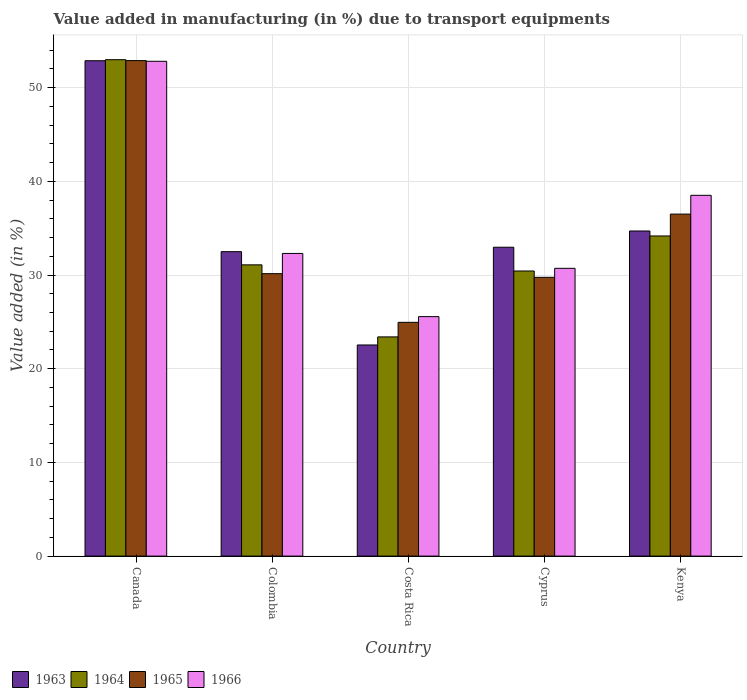How many different coloured bars are there?
Provide a succinct answer. 4. Are the number of bars on each tick of the X-axis equal?
Keep it short and to the point. Yes. What is the percentage of value added in manufacturing due to transport equipments in 1965 in Costa Rica?
Give a very brief answer. 24.95. Across all countries, what is the maximum percentage of value added in manufacturing due to transport equipments in 1963?
Your answer should be compact. 52.87. Across all countries, what is the minimum percentage of value added in manufacturing due to transport equipments in 1963?
Offer a very short reply. 22.53. In which country was the percentage of value added in manufacturing due to transport equipments in 1965 minimum?
Make the answer very short. Costa Rica. What is the total percentage of value added in manufacturing due to transport equipments in 1966 in the graph?
Give a very brief answer. 179.9. What is the difference between the percentage of value added in manufacturing due to transport equipments in 1966 in Canada and that in Costa Rica?
Ensure brevity in your answer.  27.25. What is the difference between the percentage of value added in manufacturing due to transport equipments in 1965 in Cyprus and the percentage of value added in manufacturing due to transport equipments in 1963 in Colombia?
Offer a very short reply. -2.74. What is the average percentage of value added in manufacturing due to transport equipments in 1965 per country?
Offer a very short reply. 34.85. What is the difference between the percentage of value added in manufacturing due to transport equipments of/in 1964 and percentage of value added in manufacturing due to transport equipments of/in 1965 in Colombia?
Offer a very short reply. 0.94. What is the ratio of the percentage of value added in manufacturing due to transport equipments in 1966 in Costa Rica to that in Kenya?
Make the answer very short. 0.66. Is the percentage of value added in manufacturing due to transport equipments in 1964 in Colombia less than that in Cyprus?
Make the answer very short. No. Is the difference between the percentage of value added in manufacturing due to transport equipments in 1964 in Colombia and Costa Rica greater than the difference between the percentage of value added in manufacturing due to transport equipments in 1965 in Colombia and Costa Rica?
Make the answer very short. Yes. What is the difference between the highest and the second highest percentage of value added in manufacturing due to transport equipments in 1966?
Offer a terse response. -20.51. What is the difference between the highest and the lowest percentage of value added in manufacturing due to transport equipments in 1963?
Ensure brevity in your answer.  30.34. In how many countries, is the percentage of value added in manufacturing due to transport equipments in 1964 greater than the average percentage of value added in manufacturing due to transport equipments in 1964 taken over all countries?
Give a very brief answer. 1. What does the 3rd bar from the left in Canada represents?
Make the answer very short. 1965. What does the 2nd bar from the right in Costa Rica represents?
Make the answer very short. 1965. How many countries are there in the graph?
Provide a short and direct response. 5. What is the difference between two consecutive major ticks on the Y-axis?
Provide a succinct answer. 10. Are the values on the major ticks of Y-axis written in scientific E-notation?
Ensure brevity in your answer.  No. Does the graph contain grids?
Provide a succinct answer. Yes. What is the title of the graph?
Make the answer very short. Value added in manufacturing (in %) due to transport equipments. What is the label or title of the X-axis?
Your response must be concise. Country. What is the label or title of the Y-axis?
Make the answer very short. Value added (in %). What is the Value added (in %) of 1963 in Canada?
Offer a terse response. 52.87. What is the Value added (in %) in 1964 in Canada?
Offer a terse response. 52.98. What is the Value added (in %) of 1965 in Canada?
Keep it short and to the point. 52.89. What is the Value added (in %) in 1966 in Canada?
Your answer should be compact. 52.81. What is the Value added (in %) of 1963 in Colombia?
Your answer should be very brief. 32.49. What is the Value added (in %) of 1964 in Colombia?
Make the answer very short. 31.09. What is the Value added (in %) in 1965 in Colombia?
Offer a terse response. 30.15. What is the Value added (in %) in 1966 in Colombia?
Make the answer very short. 32.3. What is the Value added (in %) of 1963 in Costa Rica?
Offer a terse response. 22.53. What is the Value added (in %) of 1964 in Costa Rica?
Offer a very short reply. 23.4. What is the Value added (in %) in 1965 in Costa Rica?
Your answer should be compact. 24.95. What is the Value added (in %) of 1966 in Costa Rica?
Ensure brevity in your answer.  25.56. What is the Value added (in %) in 1963 in Cyprus?
Your answer should be compact. 32.97. What is the Value added (in %) in 1964 in Cyprus?
Your answer should be very brief. 30.43. What is the Value added (in %) in 1965 in Cyprus?
Offer a very short reply. 29.75. What is the Value added (in %) in 1966 in Cyprus?
Your answer should be very brief. 30.72. What is the Value added (in %) of 1963 in Kenya?
Offer a very short reply. 34.7. What is the Value added (in %) of 1964 in Kenya?
Provide a succinct answer. 34.17. What is the Value added (in %) in 1965 in Kenya?
Your response must be concise. 36.5. What is the Value added (in %) of 1966 in Kenya?
Provide a short and direct response. 38.51. Across all countries, what is the maximum Value added (in %) in 1963?
Your response must be concise. 52.87. Across all countries, what is the maximum Value added (in %) of 1964?
Ensure brevity in your answer.  52.98. Across all countries, what is the maximum Value added (in %) in 1965?
Offer a terse response. 52.89. Across all countries, what is the maximum Value added (in %) in 1966?
Ensure brevity in your answer.  52.81. Across all countries, what is the minimum Value added (in %) in 1963?
Give a very brief answer. 22.53. Across all countries, what is the minimum Value added (in %) in 1964?
Give a very brief answer. 23.4. Across all countries, what is the minimum Value added (in %) in 1965?
Your answer should be very brief. 24.95. Across all countries, what is the minimum Value added (in %) of 1966?
Offer a very short reply. 25.56. What is the total Value added (in %) of 1963 in the graph?
Provide a short and direct response. 175.57. What is the total Value added (in %) of 1964 in the graph?
Ensure brevity in your answer.  172.06. What is the total Value added (in %) of 1965 in the graph?
Offer a very short reply. 174.24. What is the total Value added (in %) of 1966 in the graph?
Provide a succinct answer. 179.9. What is the difference between the Value added (in %) in 1963 in Canada and that in Colombia?
Your answer should be very brief. 20.38. What is the difference between the Value added (in %) of 1964 in Canada and that in Colombia?
Provide a succinct answer. 21.9. What is the difference between the Value added (in %) in 1965 in Canada and that in Colombia?
Offer a terse response. 22.74. What is the difference between the Value added (in %) of 1966 in Canada and that in Colombia?
Make the answer very short. 20.51. What is the difference between the Value added (in %) of 1963 in Canada and that in Costa Rica?
Provide a succinct answer. 30.34. What is the difference between the Value added (in %) in 1964 in Canada and that in Costa Rica?
Provide a succinct answer. 29.59. What is the difference between the Value added (in %) in 1965 in Canada and that in Costa Rica?
Your answer should be compact. 27.93. What is the difference between the Value added (in %) in 1966 in Canada and that in Costa Rica?
Your answer should be compact. 27.25. What is the difference between the Value added (in %) of 1963 in Canada and that in Cyprus?
Ensure brevity in your answer.  19.91. What is the difference between the Value added (in %) of 1964 in Canada and that in Cyprus?
Your response must be concise. 22.55. What is the difference between the Value added (in %) of 1965 in Canada and that in Cyprus?
Your answer should be very brief. 23.13. What is the difference between the Value added (in %) in 1966 in Canada and that in Cyprus?
Your answer should be very brief. 22.1. What is the difference between the Value added (in %) of 1963 in Canada and that in Kenya?
Your answer should be very brief. 18.17. What is the difference between the Value added (in %) in 1964 in Canada and that in Kenya?
Your answer should be very brief. 18.81. What is the difference between the Value added (in %) of 1965 in Canada and that in Kenya?
Provide a short and direct response. 16.38. What is the difference between the Value added (in %) in 1966 in Canada and that in Kenya?
Your answer should be very brief. 14.3. What is the difference between the Value added (in %) of 1963 in Colombia and that in Costa Rica?
Offer a terse response. 9.96. What is the difference between the Value added (in %) of 1964 in Colombia and that in Costa Rica?
Your response must be concise. 7.69. What is the difference between the Value added (in %) in 1965 in Colombia and that in Costa Rica?
Make the answer very short. 5.2. What is the difference between the Value added (in %) in 1966 in Colombia and that in Costa Rica?
Your answer should be compact. 6.74. What is the difference between the Value added (in %) in 1963 in Colombia and that in Cyprus?
Your answer should be compact. -0.47. What is the difference between the Value added (in %) in 1964 in Colombia and that in Cyprus?
Offer a very short reply. 0.66. What is the difference between the Value added (in %) in 1965 in Colombia and that in Cyprus?
Provide a succinct answer. 0.39. What is the difference between the Value added (in %) of 1966 in Colombia and that in Cyprus?
Make the answer very short. 1.59. What is the difference between the Value added (in %) in 1963 in Colombia and that in Kenya?
Ensure brevity in your answer.  -2.21. What is the difference between the Value added (in %) of 1964 in Colombia and that in Kenya?
Ensure brevity in your answer.  -3.08. What is the difference between the Value added (in %) in 1965 in Colombia and that in Kenya?
Make the answer very short. -6.36. What is the difference between the Value added (in %) in 1966 in Colombia and that in Kenya?
Give a very brief answer. -6.2. What is the difference between the Value added (in %) in 1963 in Costa Rica and that in Cyprus?
Your answer should be very brief. -10.43. What is the difference between the Value added (in %) of 1964 in Costa Rica and that in Cyprus?
Your answer should be compact. -7.03. What is the difference between the Value added (in %) of 1965 in Costa Rica and that in Cyprus?
Give a very brief answer. -4.8. What is the difference between the Value added (in %) in 1966 in Costa Rica and that in Cyprus?
Your answer should be compact. -5.16. What is the difference between the Value added (in %) in 1963 in Costa Rica and that in Kenya?
Provide a succinct answer. -12.17. What is the difference between the Value added (in %) of 1964 in Costa Rica and that in Kenya?
Offer a terse response. -10.77. What is the difference between the Value added (in %) in 1965 in Costa Rica and that in Kenya?
Ensure brevity in your answer.  -11.55. What is the difference between the Value added (in %) of 1966 in Costa Rica and that in Kenya?
Your response must be concise. -12.95. What is the difference between the Value added (in %) of 1963 in Cyprus and that in Kenya?
Offer a terse response. -1.73. What is the difference between the Value added (in %) in 1964 in Cyprus and that in Kenya?
Ensure brevity in your answer.  -3.74. What is the difference between the Value added (in %) in 1965 in Cyprus and that in Kenya?
Ensure brevity in your answer.  -6.75. What is the difference between the Value added (in %) of 1966 in Cyprus and that in Kenya?
Provide a short and direct response. -7.79. What is the difference between the Value added (in %) in 1963 in Canada and the Value added (in %) in 1964 in Colombia?
Offer a terse response. 21.79. What is the difference between the Value added (in %) in 1963 in Canada and the Value added (in %) in 1965 in Colombia?
Provide a short and direct response. 22.73. What is the difference between the Value added (in %) in 1963 in Canada and the Value added (in %) in 1966 in Colombia?
Give a very brief answer. 20.57. What is the difference between the Value added (in %) of 1964 in Canada and the Value added (in %) of 1965 in Colombia?
Provide a succinct answer. 22.84. What is the difference between the Value added (in %) in 1964 in Canada and the Value added (in %) in 1966 in Colombia?
Your response must be concise. 20.68. What is the difference between the Value added (in %) of 1965 in Canada and the Value added (in %) of 1966 in Colombia?
Offer a terse response. 20.58. What is the difference between the Value added (in %) in 1963 in Canada and the Value added (in %) in 1964 in Costa Rica?
Your answer should be compact. 29.48. What is the difference between the Value added (in %) of 1963 in Canada and the Value added (in %) of 1965 in Costa Rica?
Make the answer very short. 27.92. What is the difference between the Value added (in %) in 1963 in Canada and the Value added (in %) in 1966 in Costa Rica?
Make the answer very short. 27.31. What is the difference between the Value added (in %) in 1964 in Canada and the Value added (in %) in 1965 in Costa Rica?
Offer a very short reply. 28.03. What is the difference between the Value added (in %) of 1964 in Canada and the Value added (in %) of 1966 in Costa Rica?
Provide a short and direct response. 27.42. What is the difference between the Value added (in %) of 1965 in Canada and the Value added (in %) of 1966 in Costa Rica?
Provide a short and direct response. 27.33. What is the difference between the Value added (in %) of 1963 in Canada and the Value added (in %) of 1964 in Cyprus?
Provide a short and direct response. 22.44. What is the difference between the Value added (in %) in 1963 in Canada and the Value added (in %) in 1965 in Cyprus?
Offer a terse response. 23.12. What is the difference between the Value added (in %) of 1963 in Canada and the Value added (in %) of 1966 in Cyprus?
Your answer should be compact. 22.16. What is the difference between the Value added (in %) of 1964 in Canada and the Value added (in %) of 1965 in Cyprus?
Make the answer very short. 23.23. What is the difference between the Value added (in %) of 1964 in Canada and the Value added (in %) of 1966 in Cyprus?
Keep it short and to the point. 22.27. What is the difference between the Value added (in %) in 1965 in Canada and the Value added (in %) in 1966 in Cyprus?
Offer a terse response. 22.17. What is the difference between the Value added (in %) of 1963 in Canada and the Value added (in %) of 1964 in Kenya?
Give a very brief answer. 18.7. What is the difference between the Value added (in %) in 1963 in Canada and the Value added (in %) in 1965 in Kenya?
Your answer should be very brief. 16.37. What is the difference between the Value added (in %) of 1963 in Canada and the Value added (in %) of 1966 in Kenya?
Your answer should be very brief. 14.37. What is the difference between the Value added (in %) in 1964 in Canada and the Value added (in %) in 1965 in Kenya?
Make the answer very short. 16.48. What is the difference between the Value added (in %) of 1964 in Canada and the Value added (in %) of 1966 in Kenya?
Give a very brief answer. 14.47. What is the difference between the Value added (in %) of 1965 in Canada and the Value added (in %) of 1966 in Kenya?
Ensure brevity in your answer.  14.38. What is the difference between the Value added (in %) in 1963 in Colombia and the Value added (in %) in 1964 in Costa Rica?
Your answer should be compact. 9.1. What is the difference between the Value added (in %) of 1963 in Colombia and the Value added (in %) of 1965 in Costa Rica?
Offer a terse response. 7.54. What is the difference between the Value added (in %) in 1963 in Colombia and the Value added (in %) in 1966 in Costa Rica?
Your answer should be very brief. 6.93. What is the difference between the Value added (in %) in 1964 in Colombia and the Value added (in %) in 1965 in Costa Rica?
Your response must be concise. 6.14. What is the difference between the Value added (in %) in 1964 in Colombia and the Value added (in %) in 1966 in Costa Rica?
Ensure brevity in your answer.  5.53. What is the difference between the Value added (in %) of 1965 in Colombia and the Value added (in %) of 1966 in Costa Rica?
Provide a succinct answer. 4.59. What is the difference between the Value added (in %) in 1963 in Colombia and the Value added (in %) in 1964 in Cyprus?
Make the answer very short. 2.06. What is the difference between the Value added (in %) of 1963 in Colombia and the Value added (in %) of 1965 in Cyprus?
Provide a succinct answer. 2.74. What is the difference between the Value added (in %) of 1963 in Colombia and the Value added (in %) of 1966 in Cyprus?
Provide a short and direct response. 1.78. What is the difference between the Value added (in %) of 1964 in Colombia and the Value added (in %) of 1965 in Cyprus?
Provide a short and direct response. 1.33. What is the difference between the Value added (in %) of 1964 in Colombia and the Value added (in %) of 1966 in Cyprus?
Your answer should be compact. 0.37. What is the difference between the Value added (in %) in 1965 in Colombia and the Value added (in %) in 1966 in Cyprus?
Your response must be concise. -0.57. What is the difference between the Value added (in %) in 1963 in Colombia and the Value added (in %) in 1964 in Kenya?
Provide a succinct answer. -1.68. What is the difference between the Value added (in %) in 1963 in Colombia and the Value added (in %) in 1965 in Kenya?
Provide a short and direct response. -4.01. What is the difference between the Value added (in %) of 1963 in Colombia and the Value added (in %) of 1966 in Kenya?
Your answer should be compact. -6.01. What is the difference between the Value added (in %) in 1964 in Colombia and the Value added (in %) in 1965 in Kenya?
Offer a very short reply. -5.42. What is the difference between the Value added (in %) in 1964 in Colombia and the Value added (in %) in 1966 in Kenya?
Keep it short and to the point. -7.42. What is the difference between the Value added (in %) of 1965 in Colombia and the Value added (in %) of 1966 in Kenya?
Make the answer very short. -8.36. What is the difference between the Value added (in %) in 1963 in Costa Rica and the Value added (in %) in 1964 in Cyprus?
Give a very brief answer. -7.9. What is the difference between the Value added (in %) in 1963 in Costa Rica and the Value added (in %) in 1965 in Cyprus?
Provide a succinct answer. -7.22. What is the difference between the Value added (in %) in 1963 in Costa Rica and the Value added (in %) in 1966 in Cyprus?
Ensure brevity in your answer.  -8.18. What is the difference between the Value added (in %) in 1964 in Costa Rica and the Value added (in %) in 1965 in Cyprus?
Your answer should be very brief. -6.36. What is the difference between the Value added (in %) of 1964 in Costa Rica and the Value added (in %) of 1966 in Cyprus?
Your answer should be very brief. -7.32. What is the difference between the Value added (in %) in 1965 in Costa Rica and the Value added (in %) in 1966 in Cyprus?
Provide a short and direct response. -5.77. What is the difference between the Value added (in %) of 1963 in Costa Rica and the Value added (in %) of 1964 in Kenya?
Make the answer very short. -11.64. What is the difference between the Value added (in %) of 1963 in Costa Rica and the Value added (in %) of 1965 in Kenya?
Keep it short and to the point. -13.97. What is the difference between the Value added (in %) of 1963 in Costa Rica and the Value added (in %) of 1966 in Kenya?
Your answer should be very brief. -15.97. What is the difference between the Value added (in %) in 1964 in Costa Rica and the Value added (in %) in 1965 in Kenya?
Make the answer very short. -13.11. What is the difference between the Value added (in %) in 1964 in Costa Rica and the Value added (in %) in 1966 in Kenya?
Make the answer very short. -15.11. What is the difference between the Value added (in %) of 1965 in Costa Rica and the Value added (in %) of 1966 in Kenya?
Your answer should be very brief. -13.56. What is the difference between the Value added (in %) in 1963 in Cyprus and the Value added (in %) in 1964 in Kenya?
Give a very brief answer. -1.2. What is the difference between the Value added (in %) in 1963 in Cyprus and the Value added (in %) in 1965 in Kenya?
Make the answer very short. -3.54. What is the difference between the Value added (in %) in 1963 in Cyprus and the Value added (in %) in 1966 in Kenya?
Offer a very short reply. -5.54. What is the difference between the Value added (in %) of 1964 in Cyprus and the Value added (in %) of 1965 in Kenya?
Make the answer very short. -6.07. What is the difference between the Value added (in %) of 1964 in Cyprus and the Value added (in %) of 1966 in Kenya?
Give a very brief answer. -8.08. What is the difference between the Value added (in %) of 1965 in Cyprus and the Value added (in %) of 1966 in Kenya?
Offer a terse response. -8.75. What is the average Value added (in %) in 1963 per country?
Ensure brevity in your answer.  35.11. What is the average Value added (in %) of 1964 per country?
Give a very brief answer. 34.41. What is the average Value added (in %) of 1965 per country?
Your answer should be very brief. 34.85. What is the average Value added (in %) of 1966 per country?
Provide a succinct answer. 35.98. What is the difference between the Value added (in %) in 1963 and Value added (in %) in 1964 in Canada?
Offer a terse response. -0.11. What is the difference between the Value added (in %) in 1963 and Value added (in %) in 1965 in Canada?
Ensure brevity in your answer.  -0.01. What is the difference between the Value added (in %) in 1963 and Value added (in %) in 1966 in Canada?
Give a very brief answer. 0.06. What is the difference between the Value added (in %) of 1964 and Value added (in %) of 1965 in Canada?
Offer a terse response. 0.1. What is the difference between the Value added (in %) of 1964 and Value added (in %) of 1966 in Canada?
Make the answer very short. 0.17. What is the difference between the Value added (in %) of 1965 and Value added (in %) of 1966 in Canada?
Your answer should be compact. 0.07. What is the difference between the Value added (in %) in 1963 and Value added (in %) in 1964 in Colombia?
Your response must be concise. 1.41. What is the difference between the Value added (in %) in 1963 and Value added (in %) in 1965 in Colombia?
Make the answer very short. 2.35. What is the difference between the Value added (in %) in 1963 and Value added (in %) in 1966 in Colombia?
Your answer should be very brief. 0.19. What is the difference between the Value added (in %) in 1964 and Value added (in %) in 1965 in Colombia?
Your answer should be compact. 0.94. What is the difference between the Value added (in %) of 1964 and Value added (in %) of 1966 in Colombia?
Offer a terse response. -1.22. What is the difference between the Value added (in %) in 1965 and Value added (in %) in 1966 in Colombia?
Your answer should be very brief. -2.16. What is the difference between the Value added (in %) of 1963 and Value added (in %) of 1964 in Costa Rica?
Your response must be concise. -0.86. What is the difference between the Value added (in %) in 1963 and Value added (in %) in 1965 in Costa Rica?
Make the answer very short. -2.42. What is the difference between the Value added (in %) in 1963 and Value added (in %) in 1966 in Costa Rica?
Give a very brief answer. -3.03. What is the difference between the Value added (in %) in 1964 and Value added (in %) in 1965 in Costa Rica?
Provide a succinct answer. -1.55. What is the difference between the Value added (in %) of 1964 and Value added (in %) of 1966 in Costa Rica?
Provide a succinct answer. -2.16. What is the difference between the Value added (in %) of 1965 and Value added (in %) of 1966 in Costa Rica?
Keep it short and to the point. -0.61. What is the difference between the Value added (in %) in 1963 and Value added (in %) in 1964 in Cyprus?
Your response must be concise. 2.54. What is the difference between the Value added (in %) in 1963 and Value added (in %) in 1965 in Cyprus?
Make the answer very short. 3.21. What is the difference between the Value added (in %) in 1963 and Value added (in %) in 1966 in Cyprus?
Your answer should be very brief. 2.25. What is the difference between the Value added (in %) of 1964 and Value added (in %) of 1965 in Cyprus?
Ensure brevity in your answer.  0.68. What is the difference between the Value added (in %) of 1964 and Value added (in %) of 1966 in Cyprus?
Ensure brevity in your answer.  -0.29. What is the difference between the Value added (in %) of 1965 and Value added (in %) of 1966 in Cyprus?
Make the answer very short. -0.96. What is the difference between the Value added (in %) in 1963 and Value added (in %) in 1964 in Kenya?
Your response must be concise. 0.53. What is the difference between the Value added (in %) in 1963 and Value added (in %) in 1965 in Kenya?
Give a very brief answer. -1.8. What is the difference between the Value added (in %) of 1963 and Value added (in %) of 1966 in Kenya?
Provide a succinct answer. -3.81. What is the difference between the Value added (in %) in 1964 and Value added (in %) in 1965 in Kenya?
Your answer should be compact. -2.33. What is the difference between the Value added (in %) of 1964 and Value added (in %) of 1966 in Kenya?
Keep it short and to the point. -4.34. What is the difference between the Value added (in %) in 1965 and Value added (in %) in 1966 in Kenya?
Ensure brevity in your answer.  -2. What is the ratio of the Value added (in %) of 1963 in Canada to that in Colombia?
Provide a short and direct response. 1.63. What is the ratio of the Value added (in %) of 1964 in Canada to that in Colombia?
Offer a very short reply. 1.7. What is the ratio of the Value added (in %) in 1965 in Canada to that in Colombia?
Make the answer very short. 1.75. What is the ratio of the Value added (in %) of 1966 in Canada to that in Colombia?
Provide a short and direct response. 1.63. What is the ratio of the Value added (in %) in 1963 in Canada to that in Costa Rica?
Provide a short and direct response. 2.35. What is the ratio of the Value added (in %) in 1964 in Canada to that in Costa Rica?
Provide a short and direct response. 2.26. What is the ratio of the Value added (in %) of 1965 in Canada to that in Costa Rica?
Your answer should be very brief. 2.12. What is the ratio of the Value added (in %) of 1966 in Canada to that in Costa Rica?
Ensure brevity in your answer.  2.07. What is the ratio of the Value added (in %) of 1963 in Canada to that in Cyprus?
Ensure brevity in your answer.  1.6. What is the ratio of the Value added (in %) of 1964 in Canada to that in Cyprus?
Ensure brevity in your answer.  1.74. What is the ratio of the Value added (in %) in 1965 in Canada to that in Cyprus?
Offer a terse response. 1.78. What is the ratio of the Value added (in %) in 1966 in Canada to that in Cyprus?
Provide a short and direct response. 1.72. What is the ratio of the Value added (in %) of 1963 in Canada to that in Kenya?
Give a very brief answer. 1.52. What is the ratio of the Value added (in %) in 1964 in Canada to that in Kenya?
Keep it short and to the point. 1.55. What is the ratio of the Value added (in %) in 1965 in Canada to that in Kenya?
Provide a succinct answer. 1.45. What is the ratio of the Value added (in %) in 1966 in Canada to that in Kenya?
Your answer should be compact. 1.37. What is the ratio of the Value added (in %) in 1963 in Colombia to that in Costa Rica?
Your answer should be compact. 1.44. What is the ratio of the Value added (in %) of 1964 in Colombia to that in Costa Rica?
Give a very brief answer. 1.33. What is the ratio of the Value added (in %) of 1965 in Colombia to that in Costa Rica?
Offer a very short reply. 1.21. What is the ratio of the Value added (in %) in 1966 in Colombia to that in Costa Rica?
Make the answer very short. 1.26. What is the ratio of the Value added (in %) of 1963 in Colombia to that in Cyprus?
Your answer should be very brief. 0.99. What is the ratio of the Value added (in %) of 1964 in Colombia to that in Cyprus?
Ensure brevity in your answer.  1.02. What is the ratio of the Value added (in %) of 1965 in Colombia to that in Cyprus?
Provide a short and direct response. 1.01. What is the ratio of the Value added (in %) of 1966 in Colombia to that in Cyprus?
Offer a terse response. 1.05. What is the ratio of the Value added (in %) of 1963 in Colombia to that in Kenya?
Offer a terse response. 0.94. What is the ratio of the Value added (in %) of 1964 in Colombia to that in Kenya?
Provide a succinct answer. 0.91. What is the ratio of the Value added (in %) in 1965 in Colombia to that in Kenya?
Give a very brief answer. 0.83. What is the ratio of the Value added (in %) in 1966 in Colombia to that in Kenya?
Provide a short and direct response. 0.84. What is the ratio of the Value added (in %) of 1963 in Costa Rica to that in Cyprus?
Give a very brief answer. 0.68. What is the ratio of the Value added (in %) in 1964 in Costa Rica to that in Cyprus?
Your response must be concise. 0.77. What is the ratio of the Value added (in %) of 1965 in Costa Rica to that in Cyprus?
Provide a short and direct response. 0.84. What is the ratio of the Value added (in %) in 1966 in Costa Rica to that in Cyprus?
Ensure brevity in your answer.  0.83. What is the ratio of the Value added (in %) in 1963 in Costa Rica to that in Kenya?
Make the answer very short. 0.65. What is the ratio of the Value added (in %) in 1964 in Costa Rica to that in Kenya?
Keep it short and to the point. 0.68. What is the ratio of the Value added (in %) in 1965 in Costa Rica to that in Kenya?
Provide a short and direct response. 0.68. What is the ratio of the Value added (in %) in 1966 in Costa Rica to that in Kenya?
Provide a succinct answer. 0.66. What is the ratio of the Value added (in %) of 1963 in Cyprus to that in Kenya?
Offer a terse response. 0.95. What is the ratio of the Value added (in %) in 1964 in Cyprus to that in Kenya?
Keep it short and to the point. 0.89. What is the ratio of the Value added (in %) of 1965 in Cyprus to that in Kenya?
Ensure brevity in your answer.  0.82. What is the ratio of the Value added (in %) in 1966 in Cyprus to that in Kenya?
Keep it short and to the point. 0.8. What is the difference between the highest and the second highest Value added (in %) in 1963?
Your answer should be very brief. 18.17. What is the difference between the highest and the second highest Value added (in %) of 1964?
Your response must be concise. 18.81. What is the difference between the highest and the second highest Value added (in %) of 1965?
Offer a terse response. 16.38. What is the difference between the highest and the second highest Value added (in %) in 1966?
Your answer should be very brief. 14.3. What is the difference between the highest and the lowest Value added (in %) in 1963?
Your answer should be compact. 30.34. What is the difference between the highest and the lowest Value added (in %) of 1964?
Keep it short and to the point. 29.59. What is the difference between the highest and the lowest Value added (in %) in 1965?
Your response must be concise. 27.93. What is the difference between the highest and the lowest Value added (in %) of 1966?
Your answer should be compact. 27.25. 